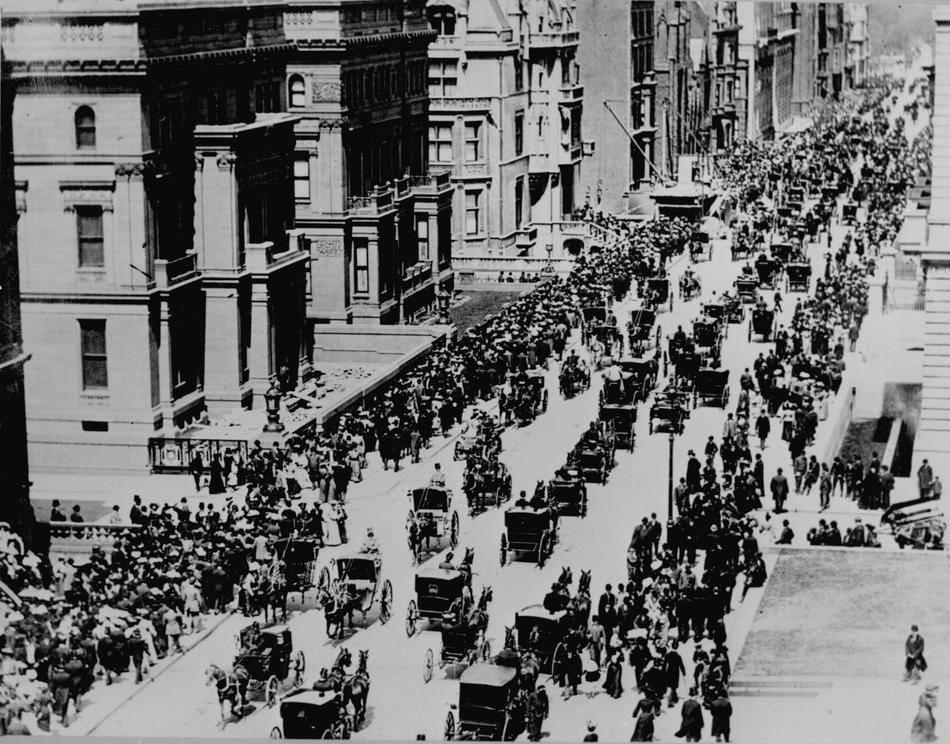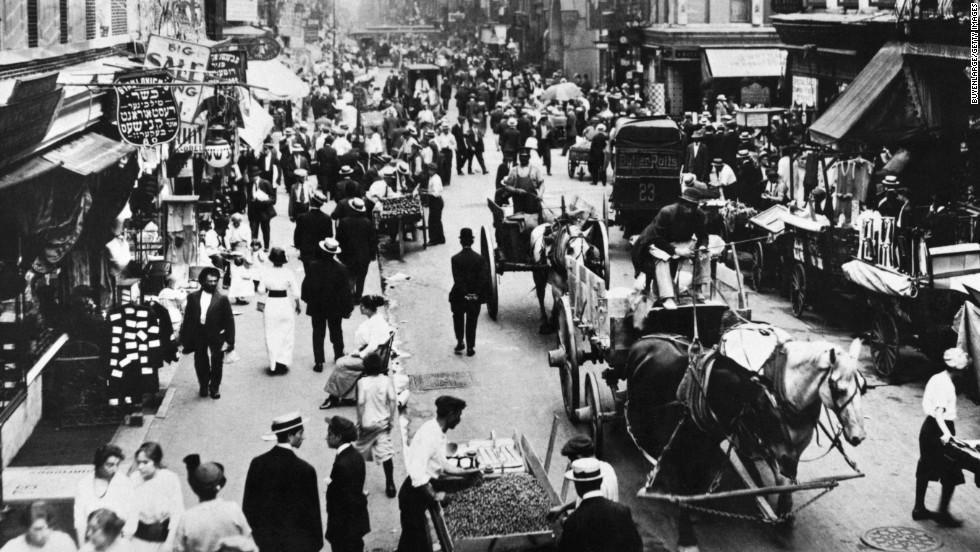The first image is the image on the left, the second image is the image on the right. Analyze the images presented: Is the assertion "In the foreground of the right image, at least one dark horse is pulling a four-wheeled carriage driven by a man in a hat, suit and white shirt, holding a stick." valid? Answer yes or no. No. The first image is the image on the left, the second image is the image on the right. For the images shown, is this caption "In at least one image there are two men being pulled on a sled by one horse." true? Answer yes or no. No. 